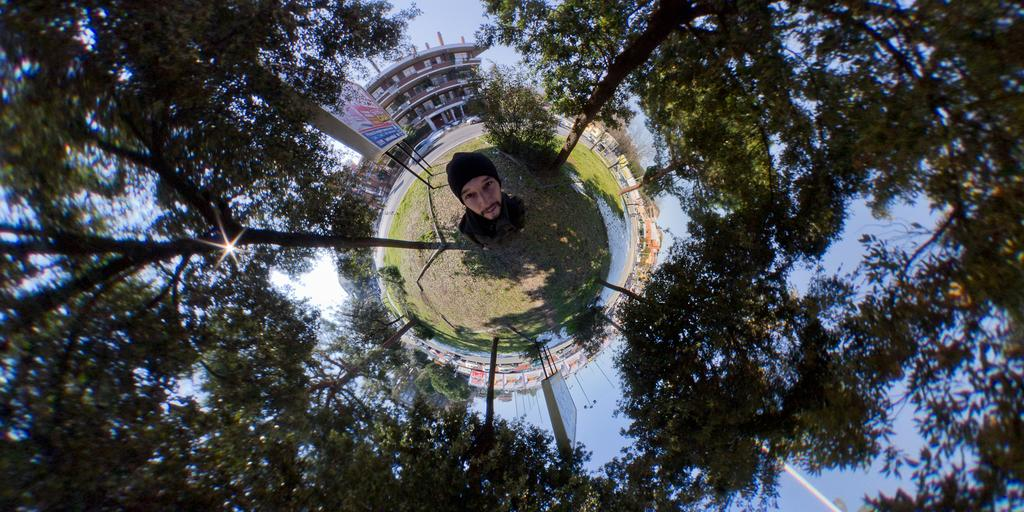What is the primary subject of the image? There is a person standing in the image. Where is the person standing? The person is standing on land. What can be seen around the person? There are plants around the person. What is visible in the background of the image? There is a building and a board in the background of the image. What is written on the board? There is text on the board. What type of music is the person playing in the image? There is no indication of music or any musical instrument in the image. How much does the letter weigh that the person is holding in the image? There is no letter present in the image, so it is not possible to determine its weight. 